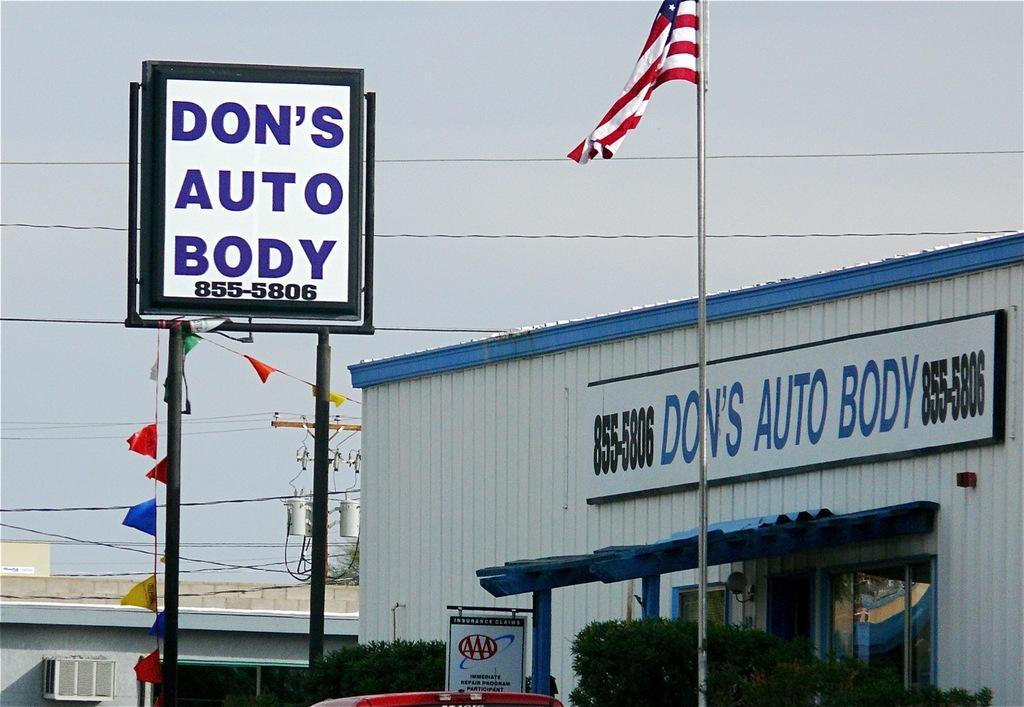In one or two sentences, can you explain what this image depicts? In this image I can see a sign board on the left hand side of the image I can see a building on the left hand side. I can see a car, a flag, a sign board, some trees, a building with a board with some text on the right hand side of the image. I can see some electrical wires and an electric pole in the center of the image. At the top of the image I can see the sky. 